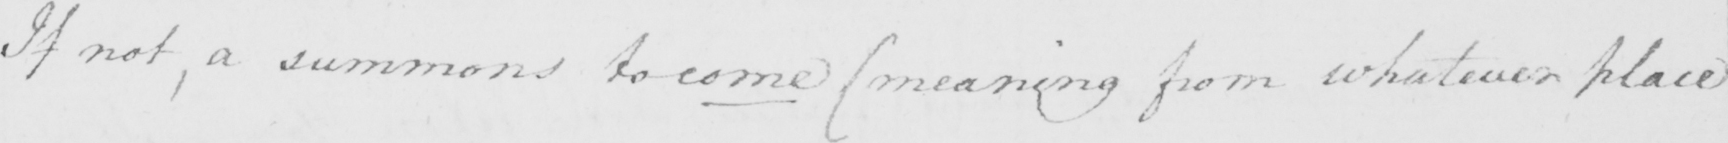Please transcribe the handwritten text in this image. If not , a summons to come  ( meaning from whatever place 